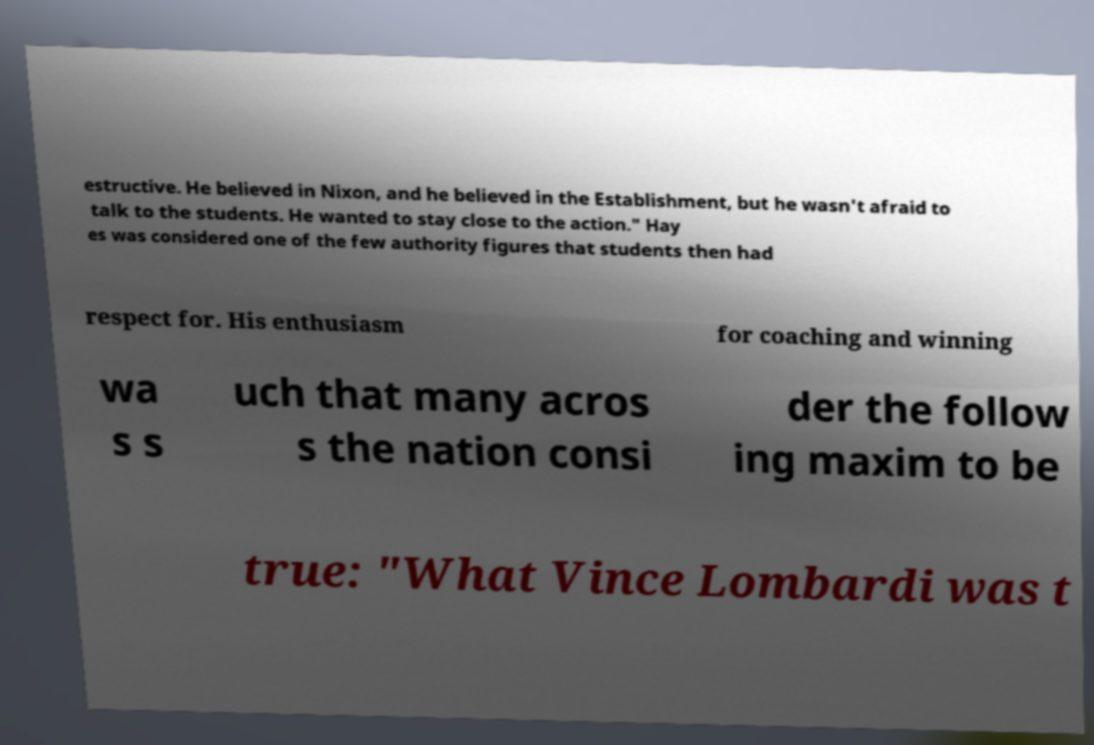Can you accurately transcribe the text from the provided image for me? estructive. He believed in Nixon, and he believed in the Establishment, but he wasn't afraid to talk to the students. He wanted to stay close to the action." Hay es was considered one of the few authority figures that students then had respect for. His enthusiasm for coaching and winning wa s s uch that many acros s the nation consi der the follow ing maxim to be true: "What Vince Lombardi was t 